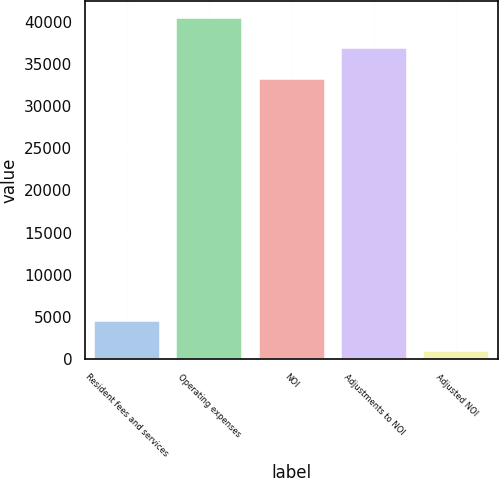<chart> <loc_0><loc_0><loc_500><loc_500><bar_chart><fcel>Resident fees and services<fcel>Operating expenses<fcel>NOI<fcel>Adjustments to NOI<fcel>Adjusted NOI<nl><fcel>4544.8<fcel>40459.6<fcel>33230<fcel>36844.8<fcel>930<nl></chart> 